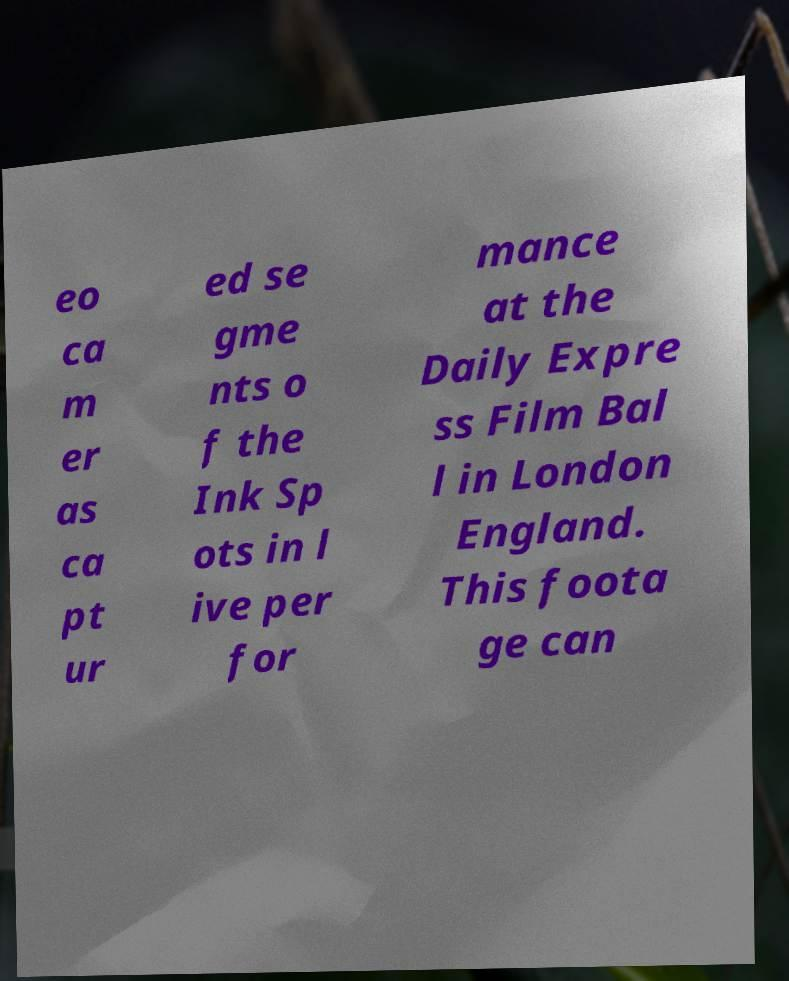Can you read and provide the text displayed in the image?This photo seems to have some interesting text. Can you extract and type it out for me? eo ca m er as ca pt ur ed se gme nts o f the Ink Sp ots in l ive per for mance at the Daily Expre ss Film Bal l in London England. This foota ge can 